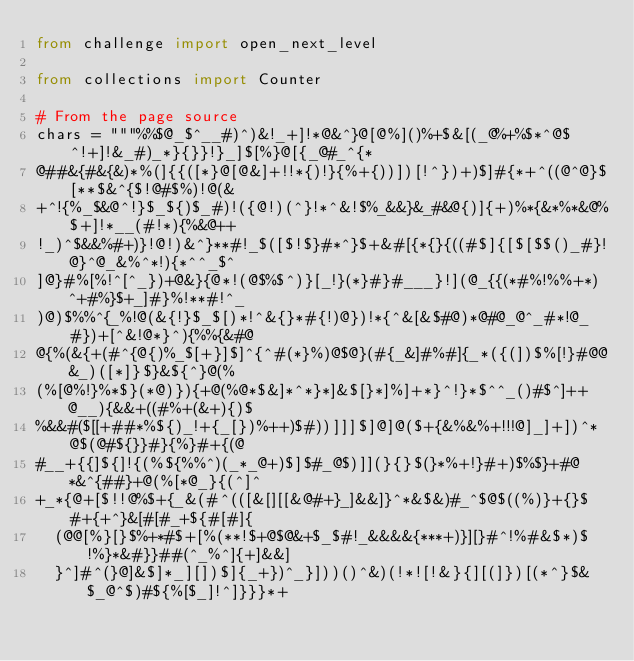<code> <loc_0><loc_0><loc_500><loc_500><_Python_>from challenge import open_next_level

from collections import Counter

# From the page source
chars = """%%$@_$^__#)^)&!_+]!*@&^}@[@%]()%+$&[(_@%+%$*^@$^!+]!&_#)_*}{}}!}_]$[%}@[{_@#_^{*
@##&{#&{&)*%(]{{([*}@[@&]+!!*{)!}{%+{))])[!^})+)$]#{*+^((@^@}$[**$&^{$!@#$%)!@(&
+^!{%_$&@^!}$_${)$_#)!({@!)(^}!*^&!$%_&&}&_#&@{)]{+)%*{&*%*&@%$+]!*__(#!*){%&@++
!_)^$&&%#+)}!@!)&^}**#!_$([$!$}#*^}$+&#[{*{}{((#$]{[$[$$()_#}!@}^@_&%^*!){*^^_$^
]@}#%[%!^[^_})+@&}{@*!(@$%$^)}[_!}(*}#}#___}!](@_{{(*#%!%%+*)^+#%}$+_]#}%!**#!^_
)@)$%%^{_%!@(&{!}$_$[)*!^&{}*#{!)@})!*{^&[&$#@)*@#@_@^_#*!@_#})+[^&!@*}^){%%{&#@
@{%(&{+(#^{@{)%_$[+}]$]^{^#(*}%)@$@}(#{_&]#%#]{_*({(])$%[!}#@@&_)([*]}$}&${^}@(%
(%[@%!}%*$}(*@)}){+@(%@*$&]*^*}*]&$[}*]%]+*}^!}*$^^_()#$^]++@__){&&+((#%+(&+){)$
%&&#($[[+##*%${)_!+{_[})%++)$#))]]]$]@]@($+{&%&%+!!!@]_]+])^*@$(@#${}}#}{%}#+{(@
#__+{{]${]!{(%${%%^)(_*_@+)$]$#_@$)]](}{}$(}*%+!}#+)$%$}+#@*&^{##}+@(%[*@_}{(^]^
+_*{@+[$!!@%$+{_&(#^(([&[][[&@#+}_]&&]}^*&$&)#_^$@$((%)}+{}$#+{+^}&[#[#_+${#[#]{
  (@@[%}[}$%+*#$+[%(**!$+@$@&+$_$#!_&&&&{***+)}][}#^!%#&$*)$!%}*&#}}##(^_%^]{+]&&]
  }^]#^(}@]&$]*_][])$]{_+})^_}]))()^&)(!*![!&}{][(]})[(*^}$&$_@^$)#${%[$_]!^]}}}*+</code> 